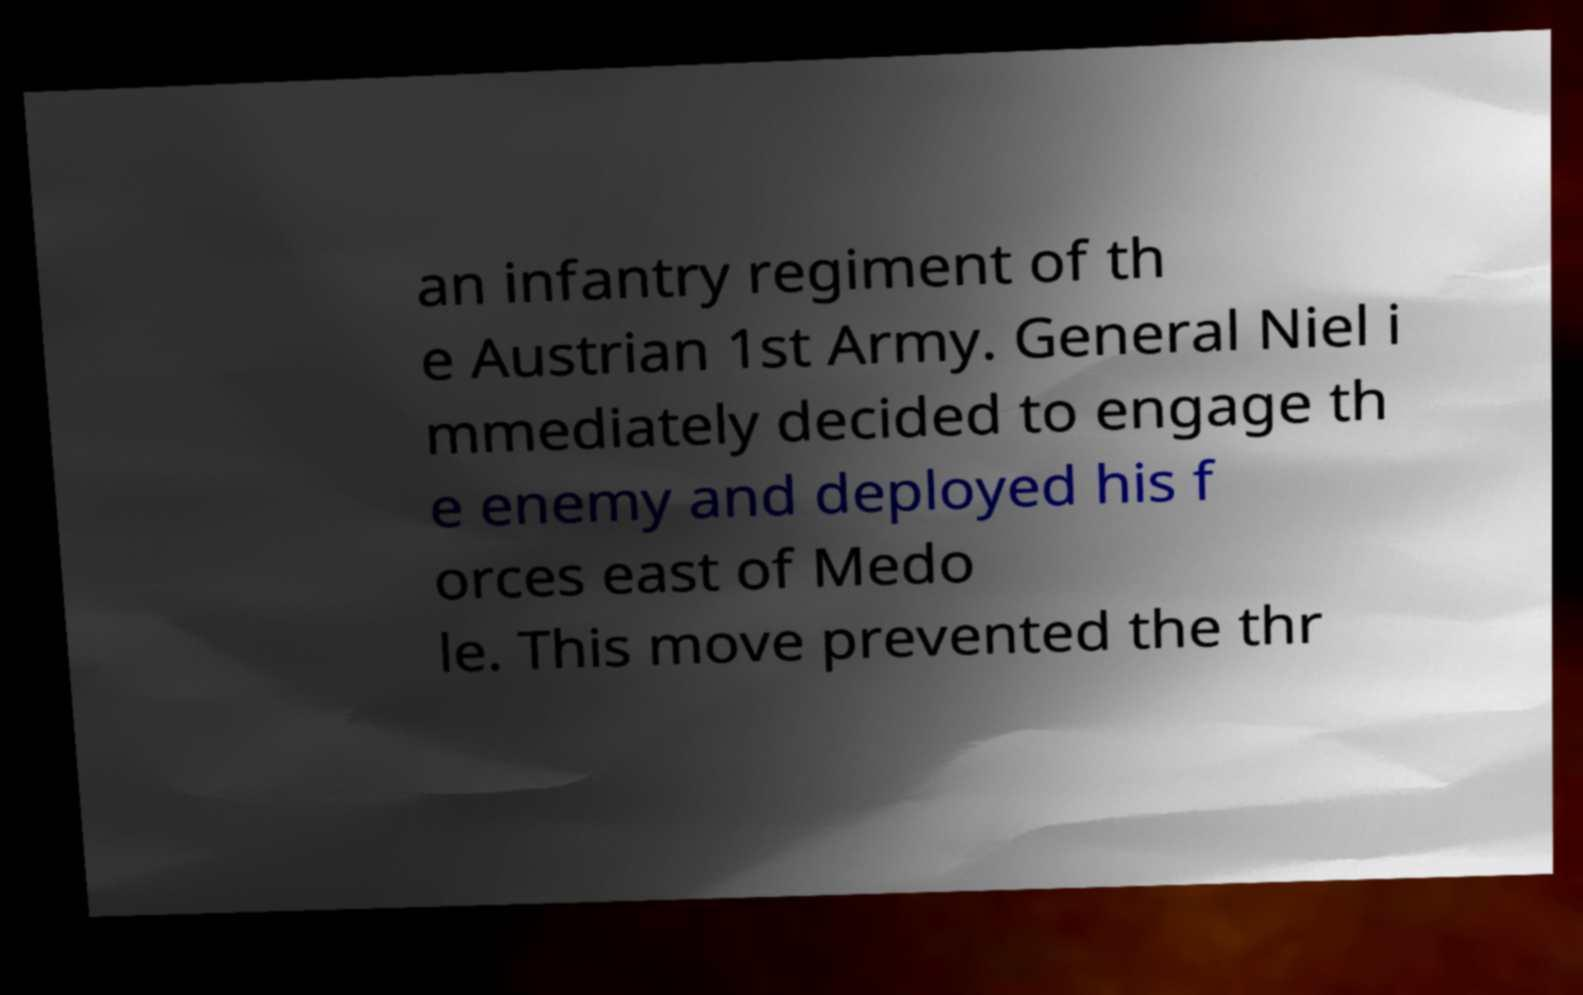For documentation purposes, I need the text within this image transcribed. Could you provide that? an infantry regiment of th e Austrian 1st Army. General Niel i mmediately decided to engage th e enemy and deployed his f orces east of Medo le. This move prevented the thr 